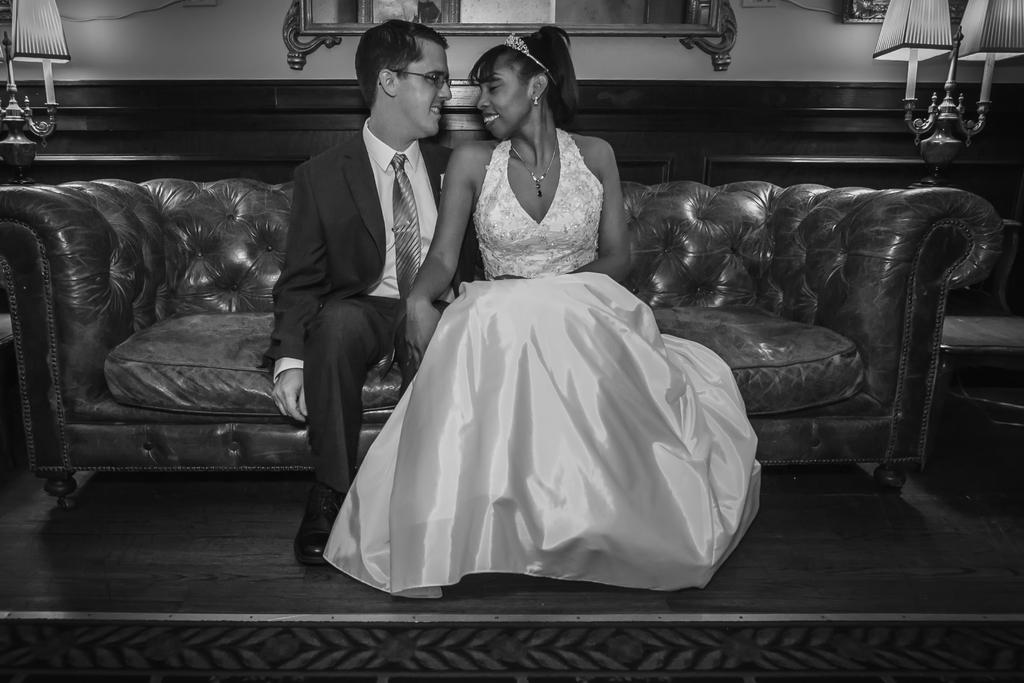How many people are sitting on the couch in the image? There are two people sitting on the couch in the image. Can you describe one of the people on the couch? One of the people is a man. What is the man wearing on his feet? The man is wearing shoes. What accessory is the man wearing on his face? The man is wearing glasses. How much anger is visible on the man's face in the image? There is no indication of anger on the man's face in the image. What type of jeans is the man wearing in the image? The man is not wearing jeans in the image; he is wearing shoes and glasses. 